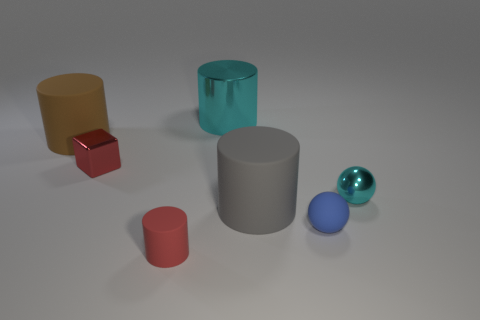Subtract 1 cylinders. How many cylinders are left? 3 Add 1 tiny blue shiny cylinders. How many objects exist? 8 Subtract all purple cylinders. Subtract all red cubes. How many cylinders are left? 4 Subtract all blocks. How many objects are left? 6 Subtract all green matte objects. Subtract all red blocks. How many objects are left? 6 Add 6 tiny blue matte things. How many tiny blue matte things are left? 7 Add 1 brown balls. How many brown balls exist? 1 Subtract 0 cyan blocks. How many objects are left? 7 